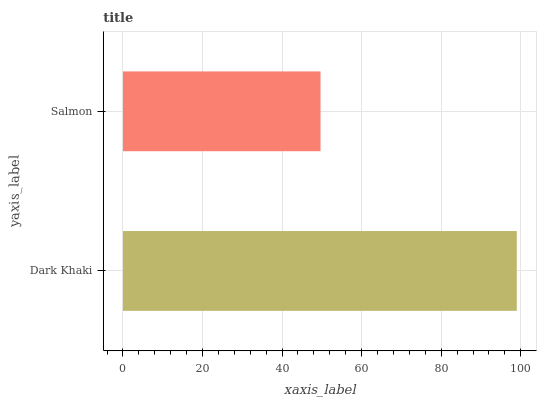Is Salmon the minimum?
Answer yes or no. Yes. Is Dark Khaki the maximum?
Answer yes or no. Yes. Is Salmon the maximum?
Answer yes or no. No. Is Dark Khaki greater than Salmon?
Answer yes or no. Yes. Is Salmon less than Dark Khaki?
Answer yes or no. Yes. Is Salmon greater than Dark Khaki?
Answer yes or no. No. Is Dark Khaki less than Salmon?
Answer yes or no. No. Is Dark Khaki the high median?
Answer yes or no. Yes. Is Salmon the low median?
Answer yes or no. Yes. Is Salmon the high median?
Answer yes or no. No. Is Dark Khaki the low median?
Answer yes or no. No. 